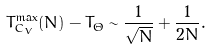<formula> <loc_0><loc_0><loc_500><loc_500>T _ { C _ { V } } ^ { \max } ( N ) - T _ { \Theta } \sim \frac { 1 } { \sqrt { N } } + \frac { 1 } { 2 { N } } .</formula> 